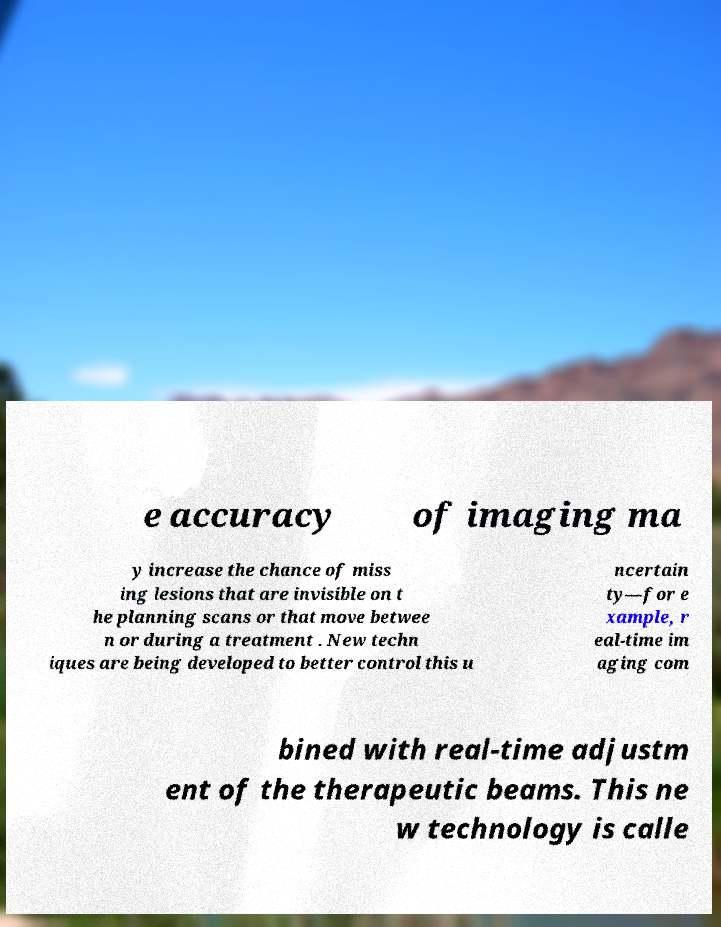Can you read and provide the text displayed in the image?This photo seems to have some interesting text. Can you extract and type it out for me? e accuracy of imaging ma y increase the chance of miss ing lesions that are invisible on t he planning scans or that move betwee n or during a treatment . New techn iques are being developed to better control this u ncertain ty—for e xample, r eal-time im aging com bined with real-time adjustm ent of the therapeutic beams. This ne w technology is calle 